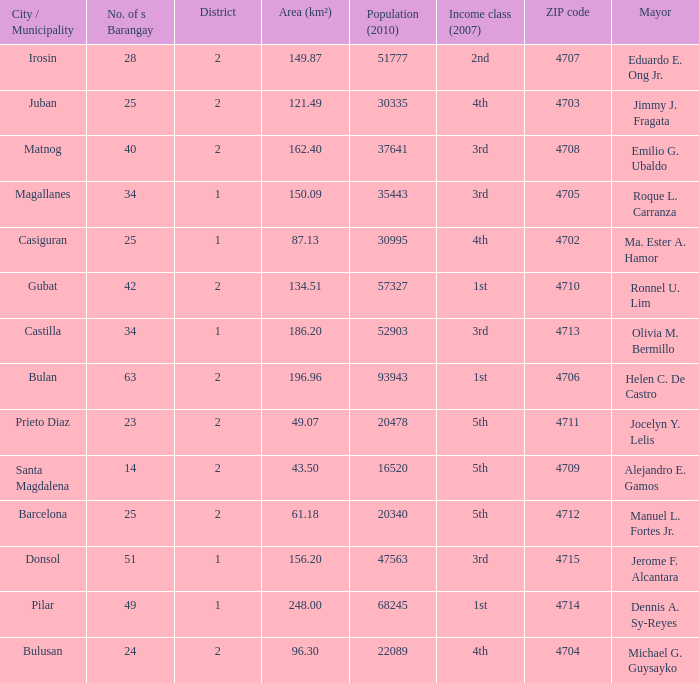What is the total quantity of populace (2010) where location (km²) is 134.51 1.0. 